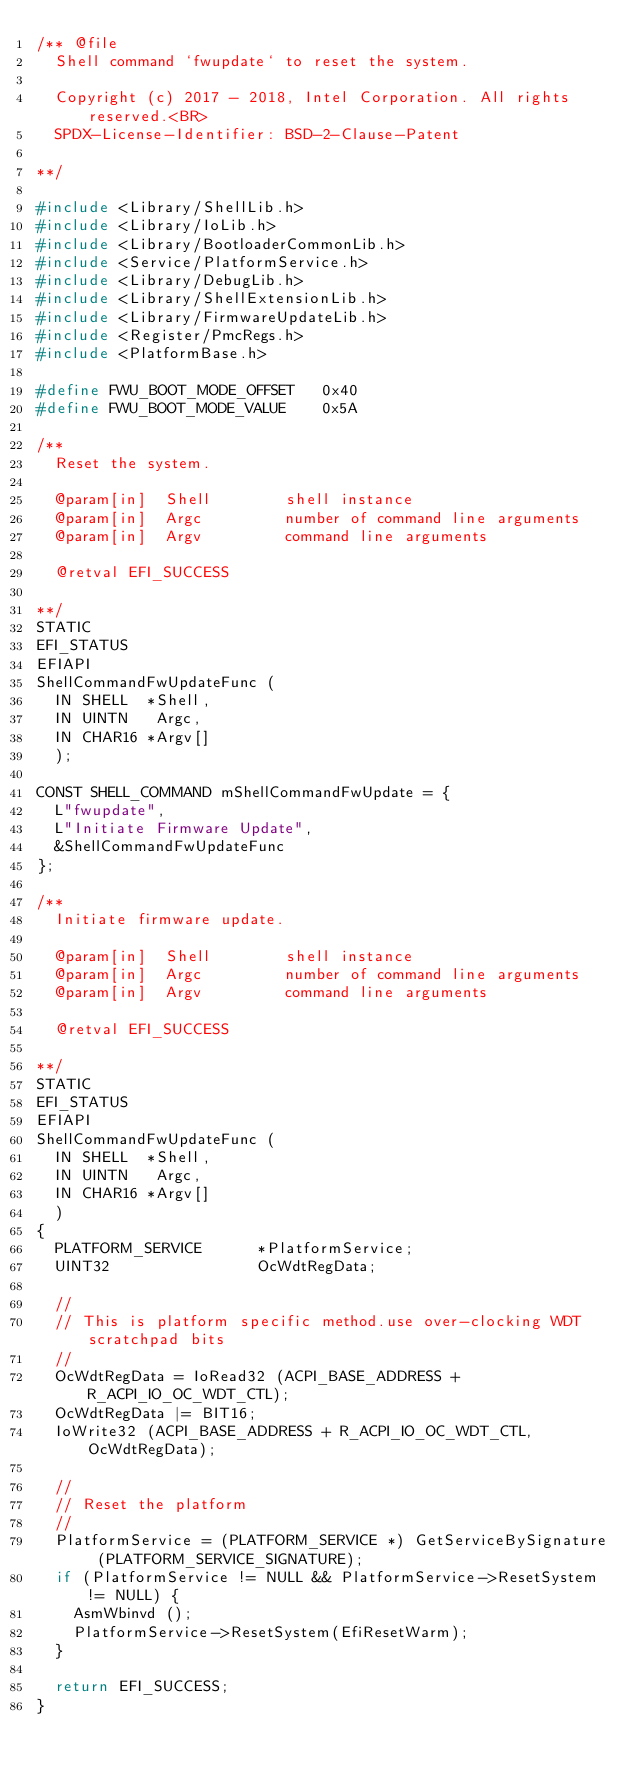<code> <loc_0><loc_0><loc_500><loc_500><_C_>/** @file
  Shell command `fwupdate` to reset the system.

  Copyright (c) 2017 - 2018, Intel Corporation. All rights reserved.<BR>
  SPDX-License-Identifier: BSD-2-Clause-Patent

**/

#include <Library/ShellLib.h>
#include <Library/IoLib.h>
#include <Library/BootloaderCommonLib.h>
#include <Service/PlatformService.h>
#include <Library/DebugLib.h>
#include <Library/ShellExtensionLib.h>
#include <Library/FirmwareUpdateLib.h>
#include <Register/PmcRegs.h>
#include <PlatformBase.h>

#define FWU_BOOT_MODE_OFFSET   0x40
#define FWU_BOOT_MODE_VALUE    0x5A

/**
  Reset the system.

  @param[in]  Shell        shell instance
  @param[in]  Argc         number of command line arguments
  @param[in]  Argv         command line arguments

  @retval EFI_SUCCESS

**/
STATIC
EFI_STATUS
EFIAPI
ShellCommandFwUpdateFunc (
  IN SHELL  *Shell,
  IN UINTN   Argc,
  IN CHAR16 *Argv[]
  );

CONST SHELL_COMMAND mShellCommandFwUpdate = {
  L"fwupdate",
  L"Initiate Firmware Update",
  &ShellCommandFwUpdateFunc
};

/**
  Initiate firmware update.

  @param[in]  Shell        shell instance
  @param[in]  Argc         number of command line arguments
  @param[in]  Argv         command line arguments

  @retval EFI_SUCCESS

**/
STATIC
EFI_STATUS
EFIAPI
ShellCommandFwUpdateFunc (
  IN SHELL  *Shell,
  IN UINTN   Argc,
  IN CHAR16 *Argv[]
  )
{
  PLATFORM_SERVICE      *PlatformService;
  UINT32                OcWdtRegData;

  //
  // This is platform specific method.use over-clocking WDT scratchpad bits
  //
  OcWdtRegData = IoRead32 (ACPI_BASE_ADDRESS + R_ACPI_IO_OC_WDT_CTL);
  OcWdtRegData |= BIT16;
  IoWrite32 (ACPI_BASE_ADDRESS + R_ACPI_IO_OC_WDT_CTL, OcWdtRegData);

  //
  // Reset the platform
  //
  PlatformService = (PLATFORM_SERVICE *) GetServiceBySignature (PLATFORM_SERVICE_SIGNATURE);
  if (PlatformService != NULL && PlatformService->ResetSystem != NULL) {
    AsmWbinvd ();
    PlatformService->ResetSystem(EfiResetWarm);
  }

  return EFI_SUCCESS;
}
</code> 